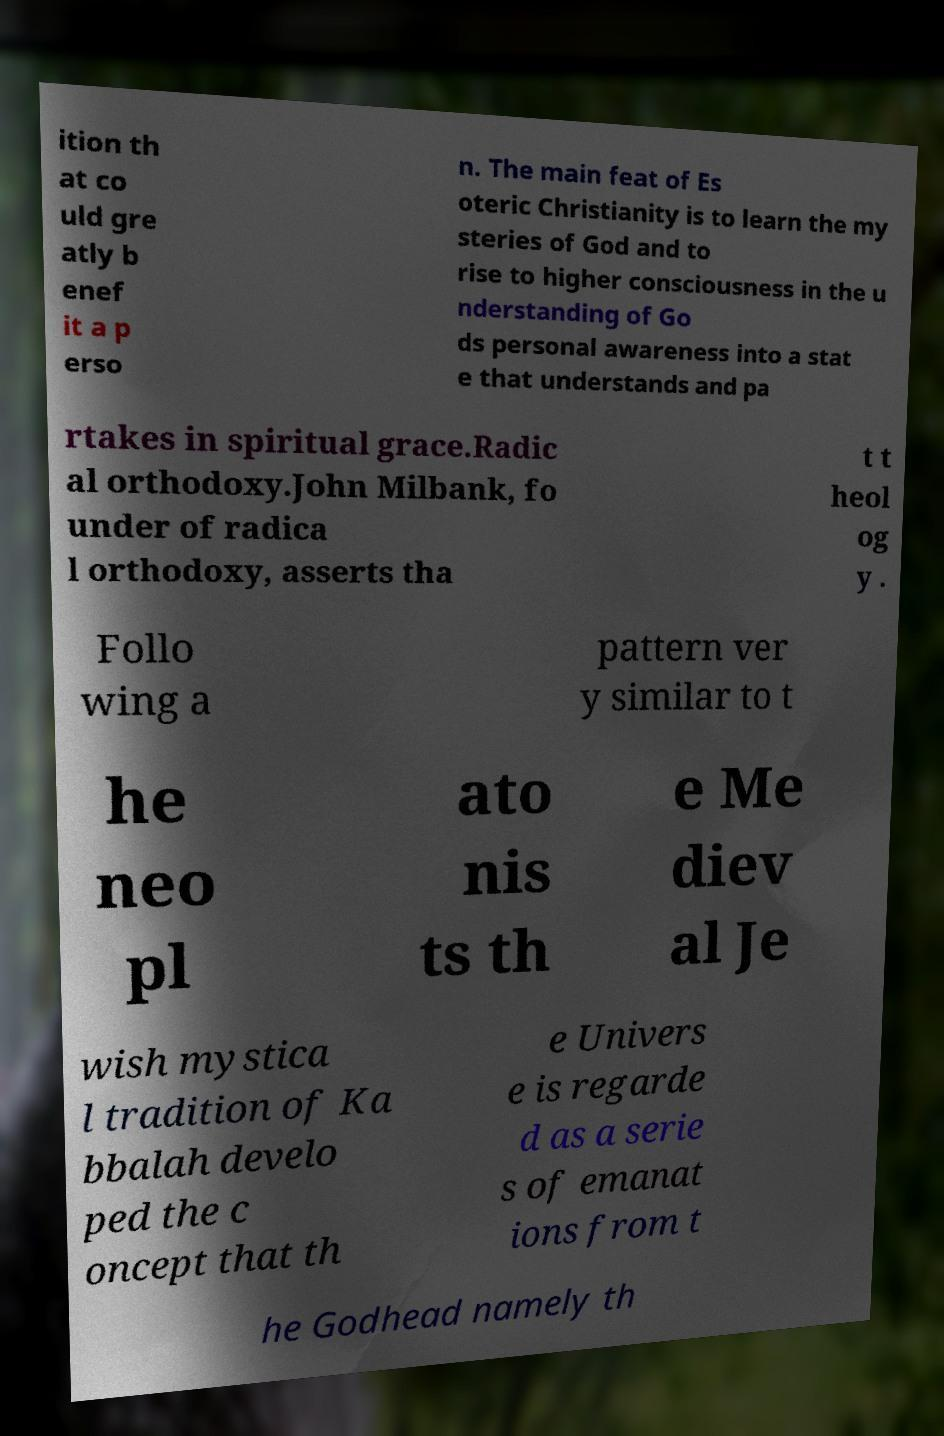Please read and relay the text visible in this image. What does it say? ition th at co uld gre atly b enef it a p erso n. The main feat of Es oteric Christianity is to learn the my steries of God and to rise to higher consciousness in the u nderstanding of Go ds personal awareness into a stat e that understands and pa rtakes in spiritual grace.Radic al orthodoxy.John Milbank, fo under of radica l orthodoxy, asserts tha t t heol og y . Follo wing a pattern ver y similar to t he neo pl ato nis ts th e Me diev al Je wish mystica l tradition of Ka bbalah develo ped the c oncept that th e Univers e is regarde d as a serie s of emanat ions from t he Godhead namely th 